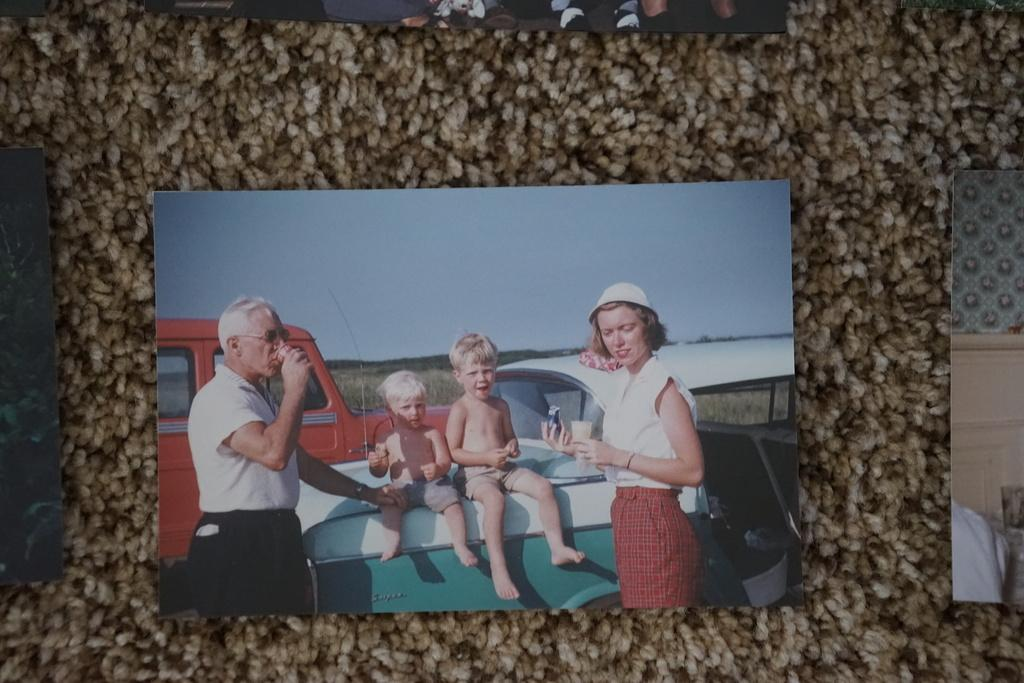What is the main subject of the image? The main subject of the image is a photocopy. What is depicted in the photocopy? The photocopy contains vehicles and persons. Can you describe the children's actions in the photocopy? Two children are sitting on a vehicle, and two children are standing and holding something. What type of fruit is being selected by the children in the image? There is no fruit present in the image; the photocopy contains vehicles and persons. What can be seen in the can that the children are holding in the image? There is no can present in the image; the children are holding something, but it is not specified as a can. 